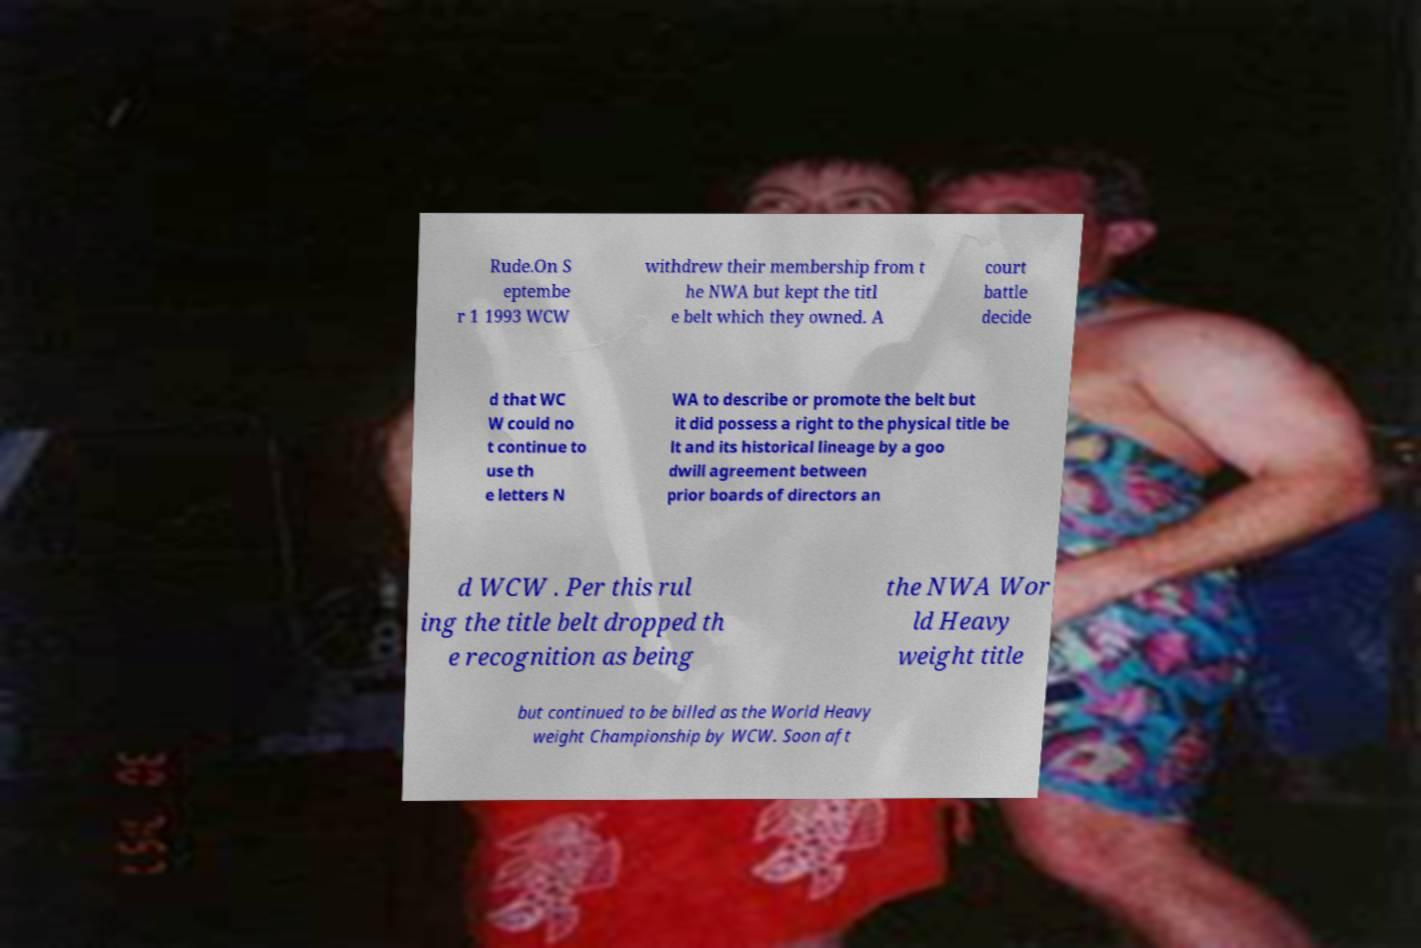I need the written content from this picture converted into text. Can you do that? Rude.On S eptembe r 1 1993 WCW withdrew their membership from t he NWA but kept the titl e belt which they owned. A court battle decide d that WC W could no t continue to use th e letters N WA to describe or promote the belt but it did possess a right to the physical title be lt and its historical lineage by a goo dwill agreement between prior boards of directors an d WCW . Per this rul ing the title belt dropped th e recognition as being the NWA Wor ld Heavy weight title but continued to be billed as the World Heavy weight Championship by WCW. Soon aft 